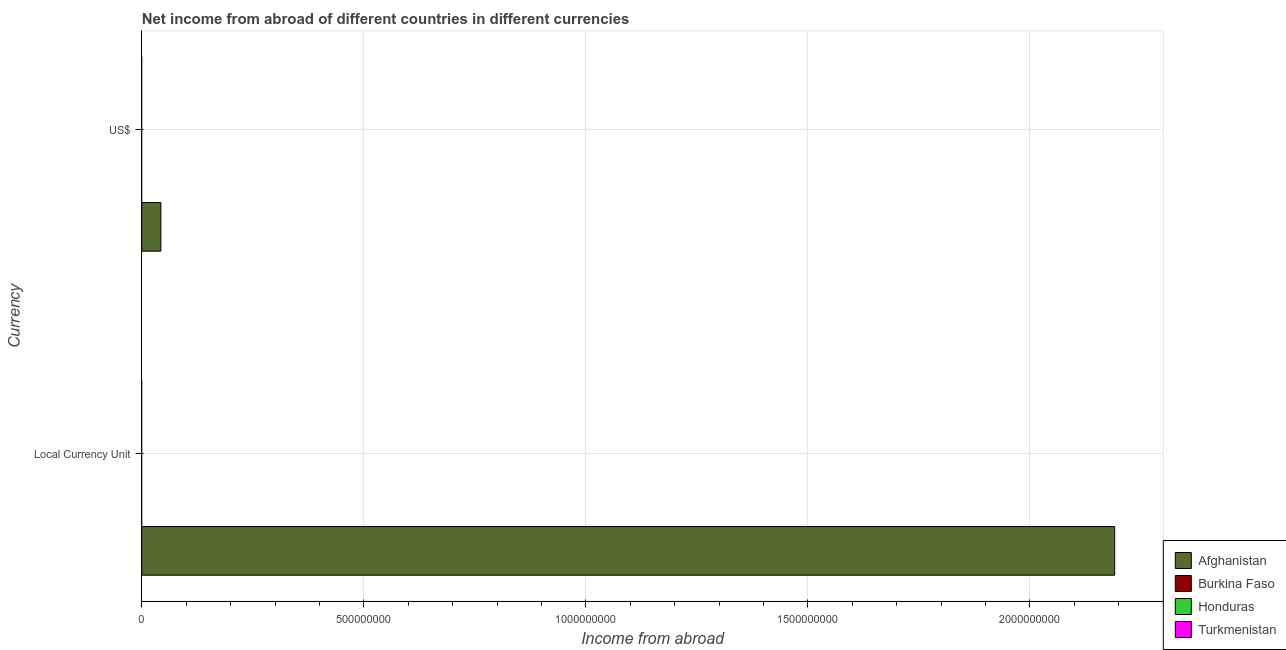How many different coloured bars are there?
Your response must be concise. 1. Are the number of bars on each tick of the Y-axis equal?
Keep it short and to the point. Yes. How many bars are there on the 2nd tick from the top?
Your response must be concise. 1. What is the label of the 1st group of bars from the top?
Your answer should be very brief. US$. What is the income from abroad in us$ in Afghanistan?
Provide a short and direct response. 4.30e+07. Across all countries, what is the maximum income from abroad in us$?
Give a very brief answer. 4.30e+07. In which country was the income from abroad in us$ maximum?
Give a very brief answer. Afghanistan. What is the total income from abroad in constant 2005 us$ in the graph?
Offer a terse response. 2.19e+09. What is the average income from abroad in us$ per country?
Your response must be concise. 1.08e+07. What is the difference between the income from abroad in constant 2005 us$ and income from abroad in us$ in Afghanistan?
Your response must be concise. 2.15e+09. How many bars are there?
Offer a very short reply. 2. How many countries are there in the graph?
Offer a very short reply. 4. Are the values on the major ticks of X-axis written in scientific E-notation?
Your response must be concise. No. Does the graph contain any zero values?
Provide a succinct answer. Yes. Does the graph contain grids?
Your answer should be compact. Yes. How many legend labels are there?
Make the answer very short. 4. What is the title of the graph?
Your answer should be compact. Net income from abroad of different countries in different currencies. Does "Ecuador" appear as one of the legend labels in the graph?
Your response must be concise. No. What is the label or title of the X-axis?
Provide a succinct answer. Income from abroad. What is the label or title of the Y-axis?
Keep it short and to the point. Currency. What is the Income from abroad of Afghanistan in Local Currency Unit?
Offer a very short reply. 2.19e+09. What is the Income from abroad of Burkina Faso in Local Currency Unit?
Provide a succinct answer. 0. What is the Income from abroad of Honduras in Local Currency Unit?
Keep it short and to the point. 0. What is the Income from abroad in Afghanistan in US$?
Provide a succinct answer. 4.30e+07. What is the Income from abroad in Honduras in US$?
Your answer should be compact. 0. Across all Currency, what is the maximum Income from abroad of Afghanistan?
Provide a succinct answer. 2.19e+09. Across all Currency, what is the minimum Income from abroad in Afghanistan?
Provide a short and direct response. 4.30e+07. What is the total Income from abroad of Afghanistan in the graph?
Provide a short and direct response. 2.23e+09. What is the total Income from abroad of Burkina Faso in the graph?
Provide a succinct answer. 0. What is the total Income from abroad in Turkmenistan in the graph?
Offer a terse response. 0. What is the difference between the Income from abroad in Afghanistan in Local Currency Unit and that in US$?
Provide a succinct answer. 2.15e+09. What is the average Income from abroad in Afghanistan per Currency?
Make the answer very short. 1.12e+09. What is the average Income from abroad in Burkina Faso per Currency?
Keep it short and to the point. 0. What is the average Income from abroad in Honduras per Currency?
Keep it short and to the point. 0. What is the average Income from abroad in Turkmenistan per Currency?
Your answer should be very brief. 0. What is the ratio of the Income from abroad in Afghanistan in Local Currency Unit to that in US$?
Make the answer very short. 50.95. What is the difference between the highest and the second highest Income from abroad of Afghanistan?
Provide a short and direct response. 2.15e+09. What is the difference between the highest and the lowest Income from abroad in Afghanistan?
Your answer should be compact. 2.15e+09. 